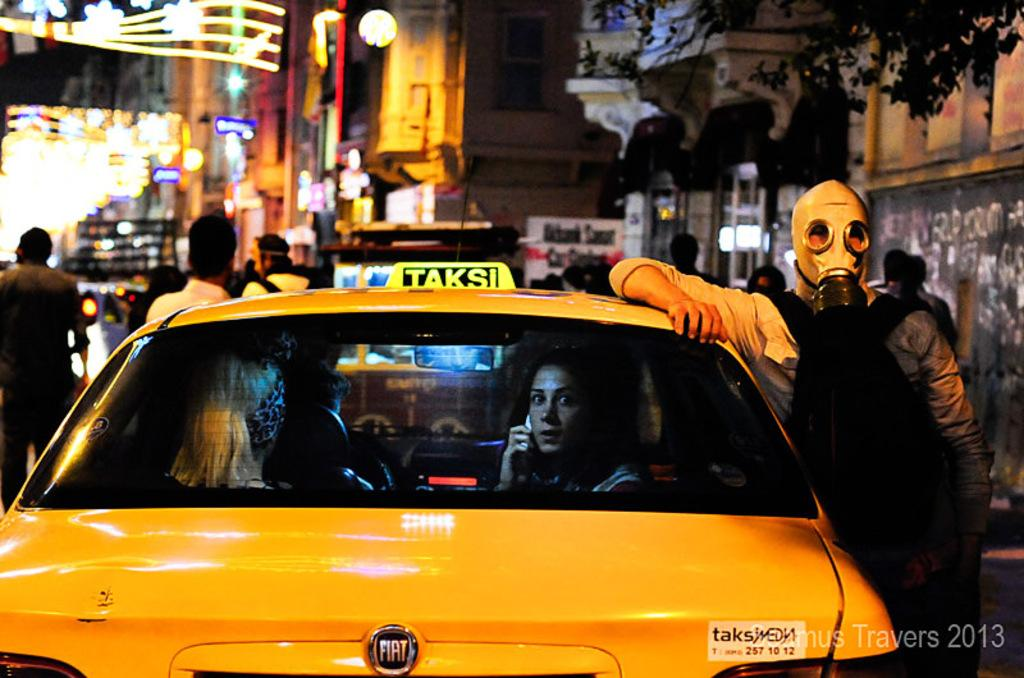<image>
Create a compact narrative representing the image presented. A yellow car made by Fiat is used as a taxi. 